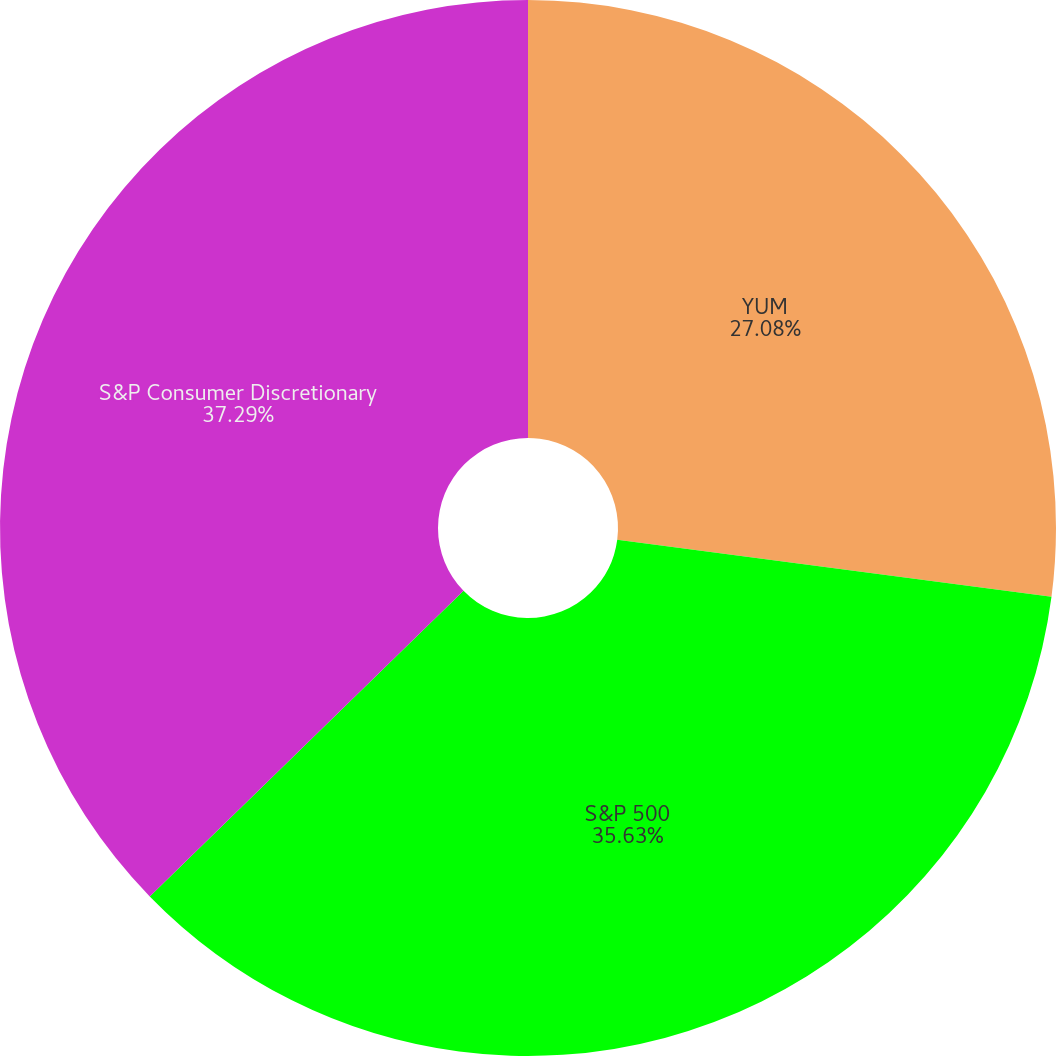<chart> <loc_0><loc_0><loc_500><loc_500><pie_chart><fcel>YUM<fcel>S&P 500<fcel>S&P Consumer Discretionary<nl><fcel>27.08%<fcel>35.63%<fcel>37.29%<nl></chart> 